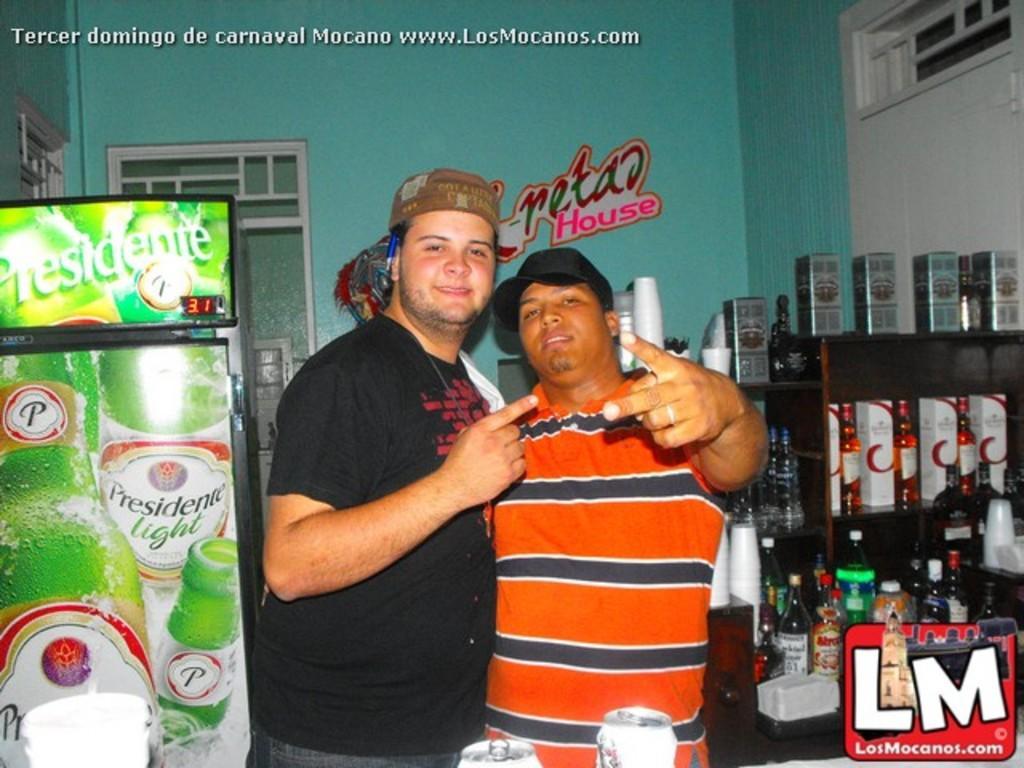How would you summarize this image in a sentence or two? In this picture we can see two boys standing in the front, smiling and giving a pose into the camera. On the right side there are some wine bottles. On the left side we can see the green color refrigerator. In the background we can see the green wall and glass window. 